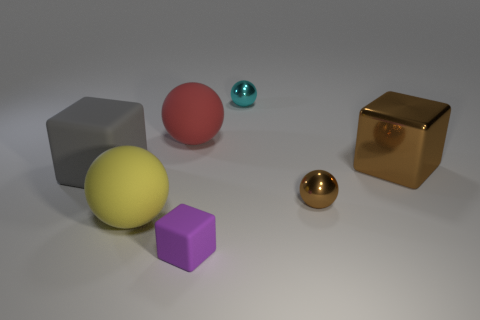Are there an equal number of cubes that are left of the brown cube and purple things? No, there are two cubes to the left of the brown cube, which is actually a brown sphere, but only one purple cube in the image. 